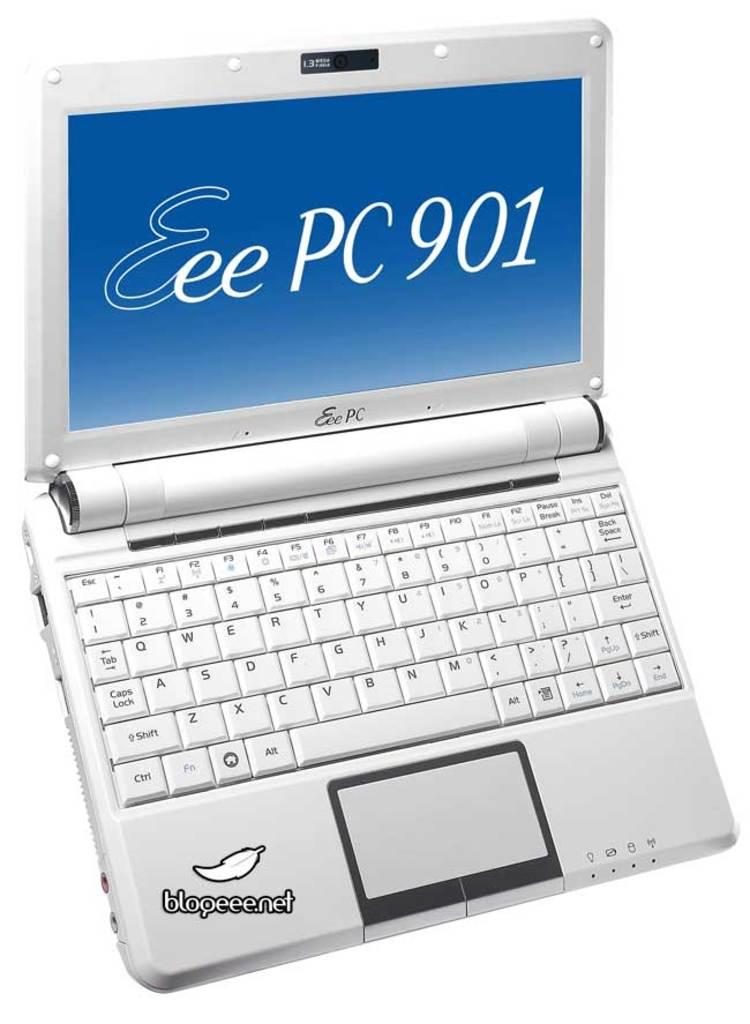What electronic device is visible in the image? There is a laptop in the image. What color is the background of the image? The background of the image is white. What type of mint can be seen growing near the laptop in the image? There is no mint present in the image; the background is white, and the focus is on the laptop. 